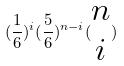Convert formula to latex. <formula><loc_0><loc_0><loc_500><loc_500>( \frac { 1 } { 6 } ) ^ { i } ( \frac { 5 } { 6 } ) ^ { n - i } ( \begin{matrix} n \\ i \end{matrix} )</formula> 